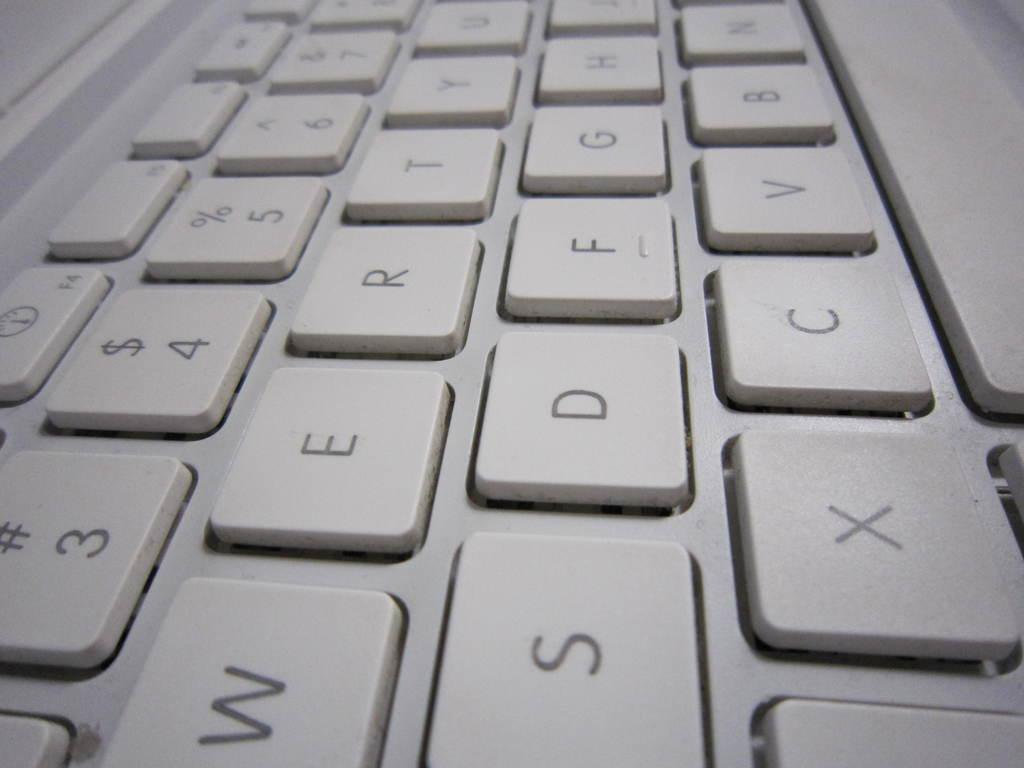Provide a one-sentence caption for the provided image. The computer's keyboard is soft in tone and is also a "QWERTY" layout. 